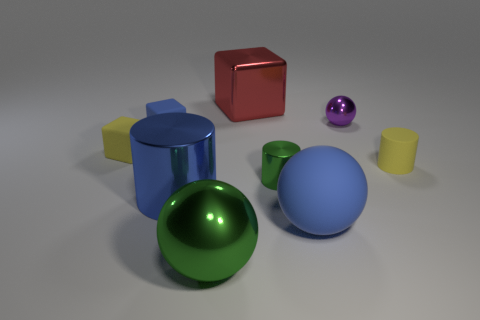What materials appear to be represented by the objects in the image? The objects in the image seem to represent various materials with different textures and reflections. For instance, you can observe that some exhibit a metallic sheen, like the spherical blue and green objects, which suggests they could be made of metal. Others, like the yellow cubes, have a matte finish, possibly representing a plastic material. 